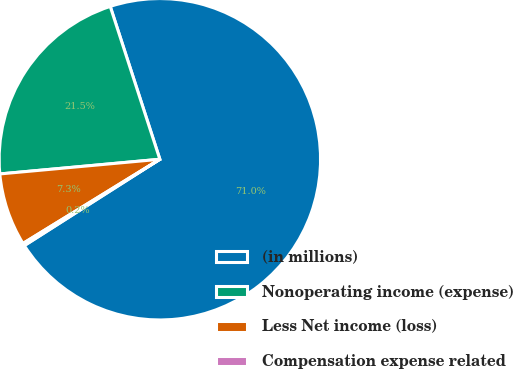Convert chart to OTSL. <chart><loc_0><loc_0><loc_500><loc_500><pie_chart><fcel>(in millions)<fcel>Nonoperating income (expense)<fcel>Less Net income (loss)<fcel>Compensation expense related<nl><fcel>70.97%<fcel>21.46%<fcel>7.32%<fcel>0.25%<nl></chart> 